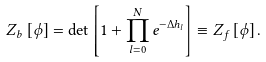Convert formula to latex. <formula><loc_0><loc_0><loc_500><loc_500>Z _ { b } \left [ \phi \right ] = \det \left [ 1 + \prod _ { l = 0 } ^ { N } e ^ { - \Delta h _ { l } } \right ] \equiv Z _ { f } \left [ \phi \right ] .</formula> 